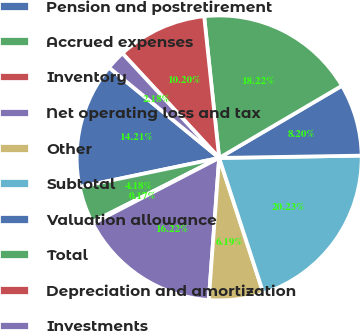<chart> <loc_0><loc_0><loc_500><loc_500><pie_chart><fcel>Pension and postretirement<fcel>Accrued expenses<fcel>Inventory<fcel>Net operating loss and tax<fcel>Other<fcel>Subtotal<fcel>Valuation allowance<fcel>Total<fcel>Depreciation and amortization<fcel>Investments<nl><fcel>14.21%<fcel>4.18%<fcel>0.17%<fcel>16.22%<fcel>6.19%<fcel>20.23%<fcel>8.2%<fcel>18.22%<fcel>10.2%<fcel>2.18%<nl></chart> 